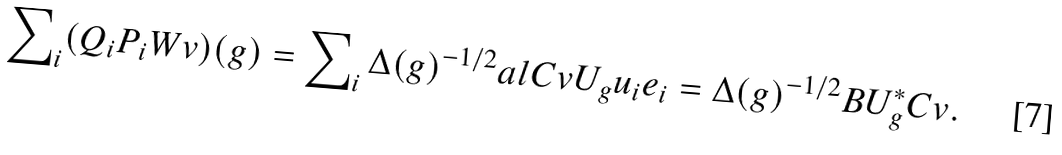<formula> <loc_0><loc_0><loc_500><loc_500>\sum \nolimits _ { i } ( Q _ { i } P _ { i } W v ) ( g ) = \sum \nolimits _ { i } \Delta ( g ) ^ { - 1 / 2 } a l { C v } { U _ { g } u _ { i } } e _ { i } = \Delta ( g ) ^ { - 1 / 2 } B U _ { g } ^ { \ast } C v .</formula> 